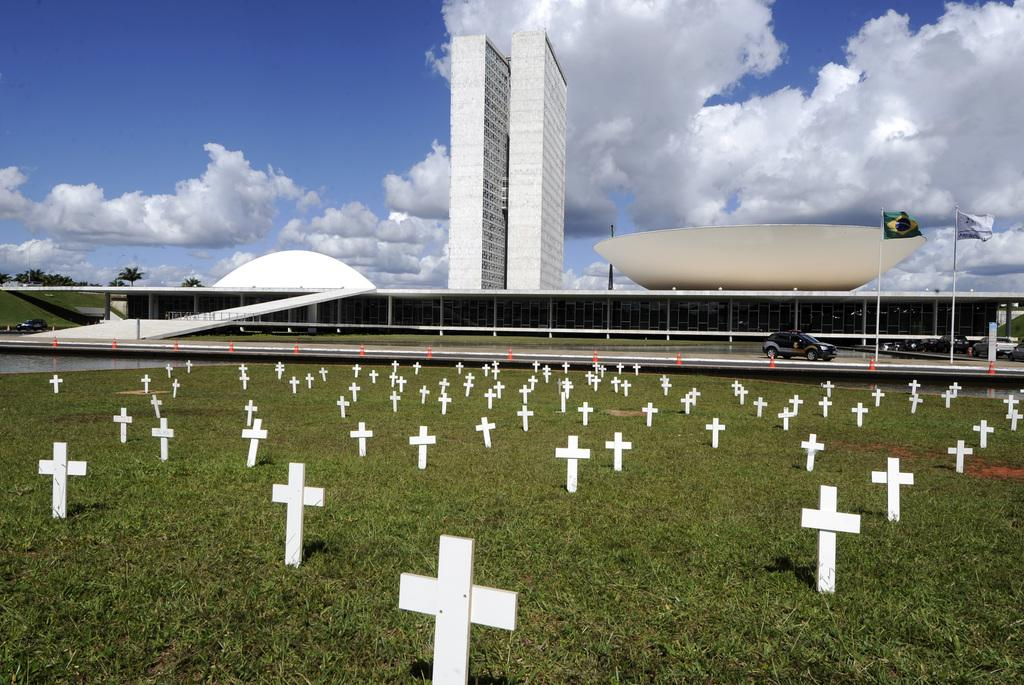What can be seen on the grass in the image? There are cross symbols on the grass. What is located on the road in the image? There is a vehicle on the road. What is attached to the poles in the image? There are flags on poles. What type of building can be seen in the image? There is a glass building in the image. What type of vegetation is present in the image? Trees are present in the image. What is visible in the background of the image? The sky with clouds is visible in the background. What type of copper material is present in the image? There is no copper material present in the image. How does the earthquake affect the glass building in the image? There is no earthquake depicted in the image, so its effect on the glass building cannot be determined. 